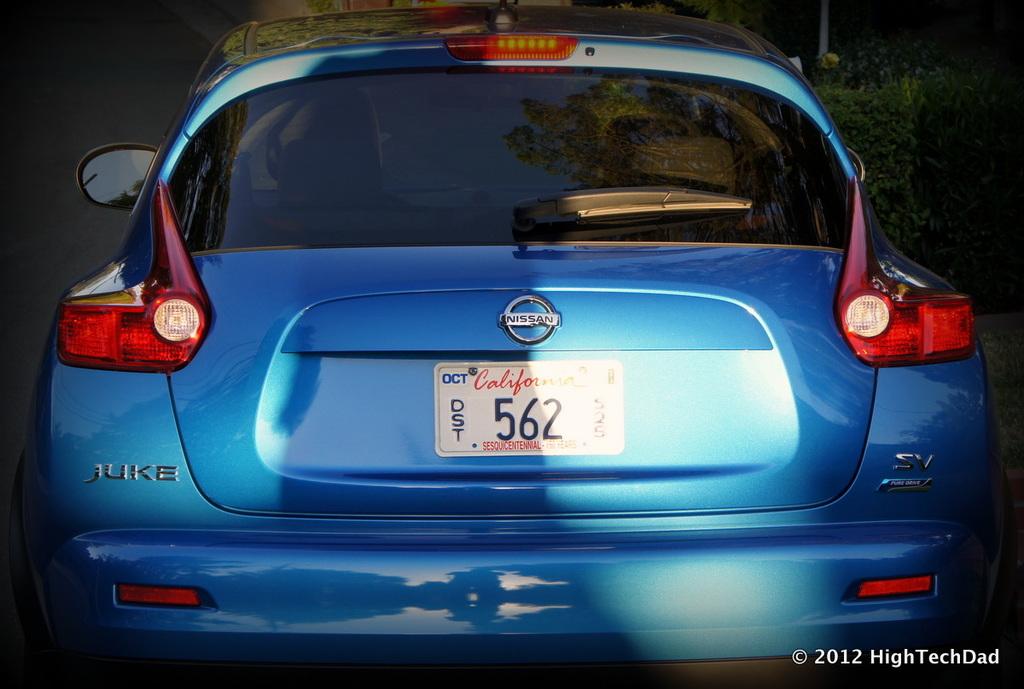What is the plate number?
Offer a very short reply. 562. 